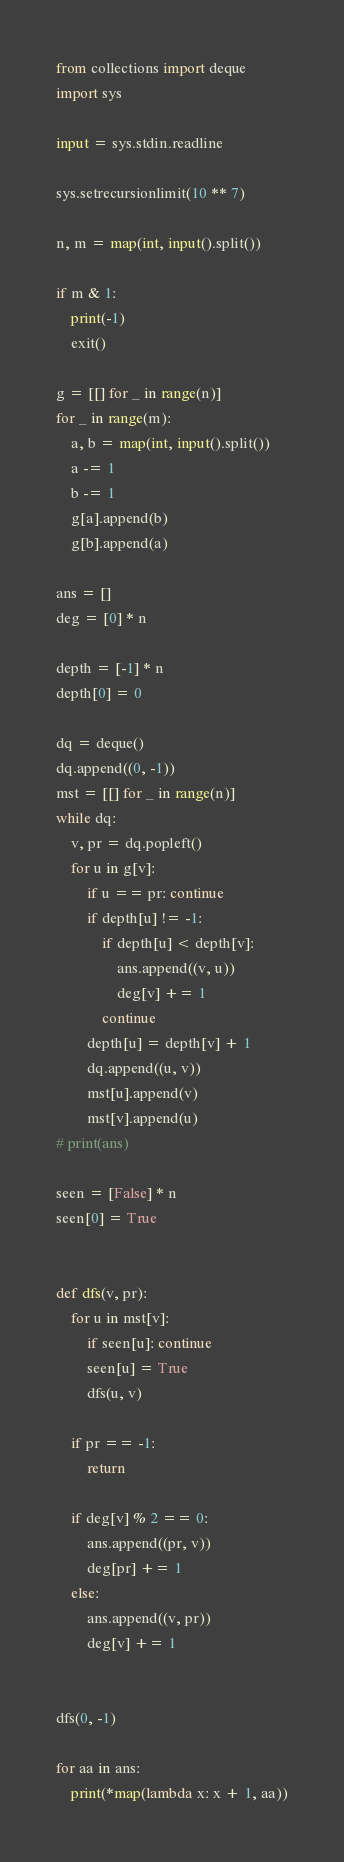Convert code to text. <code><loc_0><loc_0><loc_500><loc_500><_Python_>from collections import deque
import sys

input = sys.stdin.readline

sys.setrecursionlimit(10 ** 7)

n, m = map(int, input().split())

if m & 1:
    print(-1)
    exit()

g = [[] for _ in range(n)]
for _ in range(m):
    a, b = map(int, input().split())
    a -= 1
    b -= 1
    g[a].append(b)
    g[b].append(a)

ans = []
deg = [0] * n

depth = [-1] * n
depth[0] = 0

dq = deque()
dq.append((0, -1))
mst = [[] for _ in range(n)]
while dq:
    v, pr = dq.popleft()
    for u in g[v]:
        if u == pr: continue
        if depth[u] != -1:
            if depth[u] < depth[v]:
                ans.append((v, u))
                deg[v] += 1
            continue
        depth[u] = depth[v] + 1
        dq.append((u, v))
        mst[u].append(v)
        mst[v].append(u)
# print(ans)

seen = [False] * n
seen[0] = True


def dfs(v, pr):
    for u in mst[v]:
        if seen[u]: continue
        seen[u] = True
        dfs(u, v)

    if pr == -1:
        return

    if deg[v] % 2 == 0:
        ans.append((pr, v))
        deg[pr] += 1
    else:
        ans.append((v, pr))
        deg[v] += 1


dfs(0, -1)

for aa in ans:
    print(*map(lambda x: x + 1, aa))
</code> 